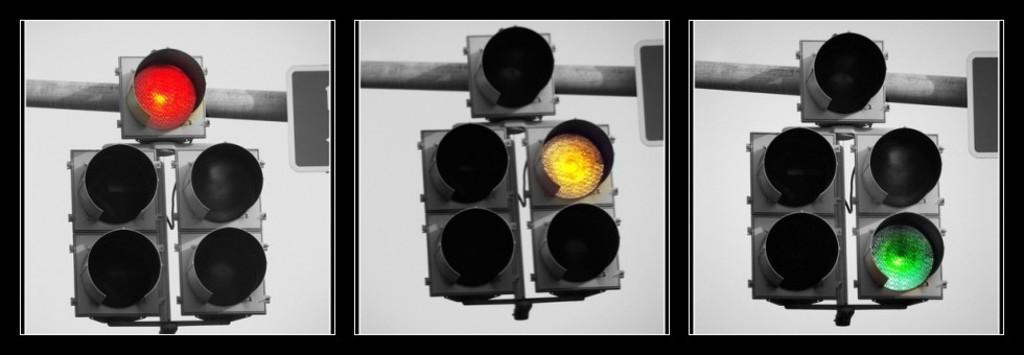Describe this image in one or two sentences. This image consists of a poster with three images of a signal light on it. In the first image of a signal light there is a red light. In the second image of a signal light there is a yellow light. In the third image of a signal light there is a green light. 